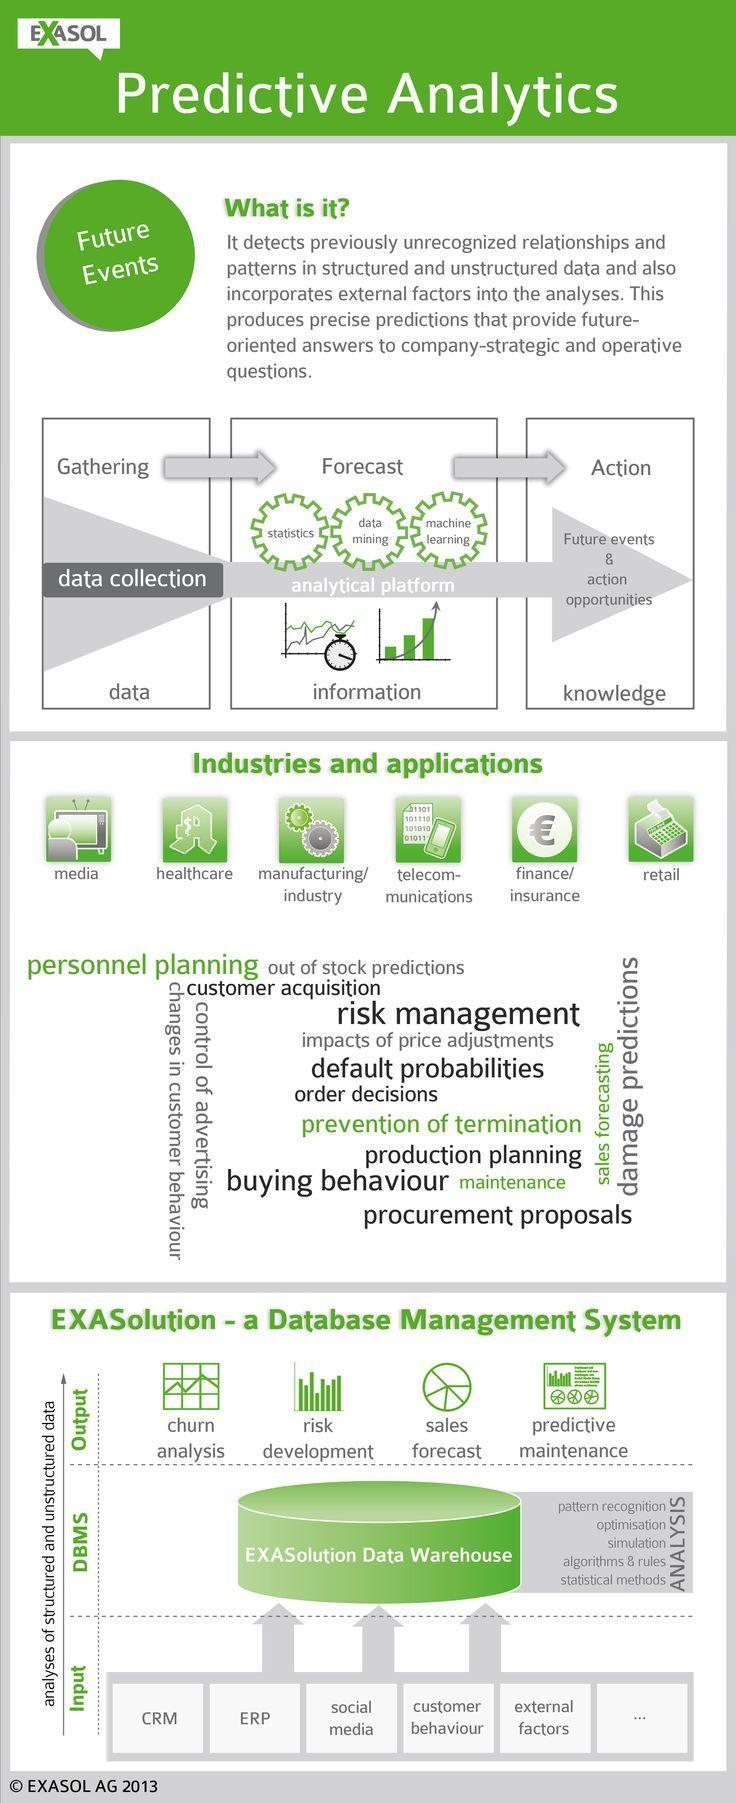How many outputs mentioned in the infographic?
Answer the question with a short phrase. 4 How many analyses performed in the EXASolution Data warehouse? 5 How many inputs mentioned in the infographic? 5 